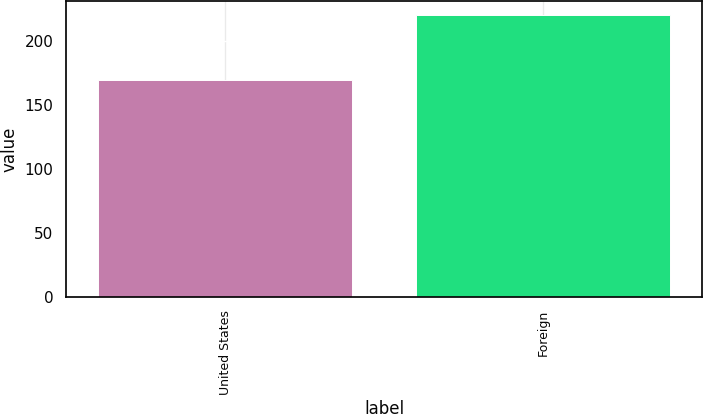Convert chart to OTSL. <chart><loc_0><loc_0><loc_500><loc_500><bar_chart><fcel>United States<fcel>Foreign<nl><fcel>169<fcel>220<nl></chart> 